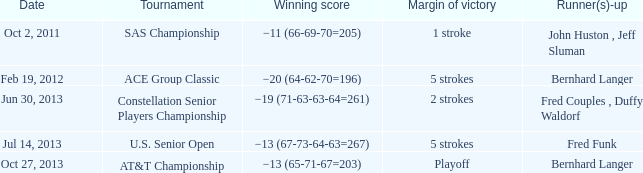Who's the second position holder(s) with a successful score of -19 (71-63-63-64=261)? Fred Couples , Duffy Waldorf. 